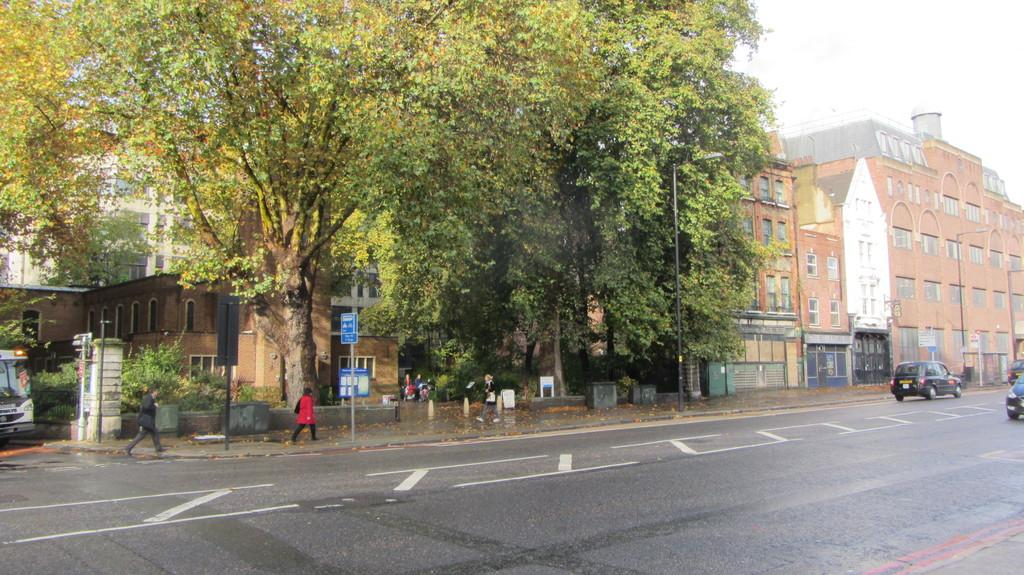What is happening on the road in the image? There are vehicles moving on a road in the image. What are people doing in the image? People are walking on a footpath in the image. What structures can be seen in the image? There are poles, trees, and buildings in the image. What type of jelly can be seen in the image? There is no jelly present in the image. What time of day is it in the image? The time of day cannot be determined from the image alone. 